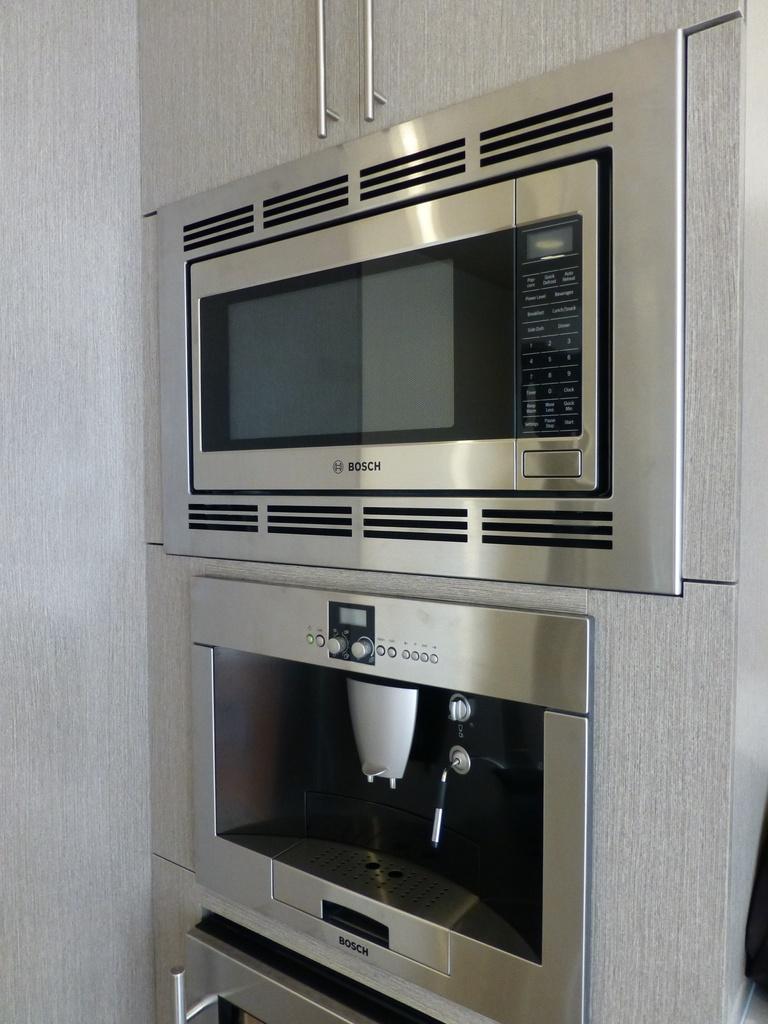What is the brand of the oven?
Give a very brief answer. Bosch. 